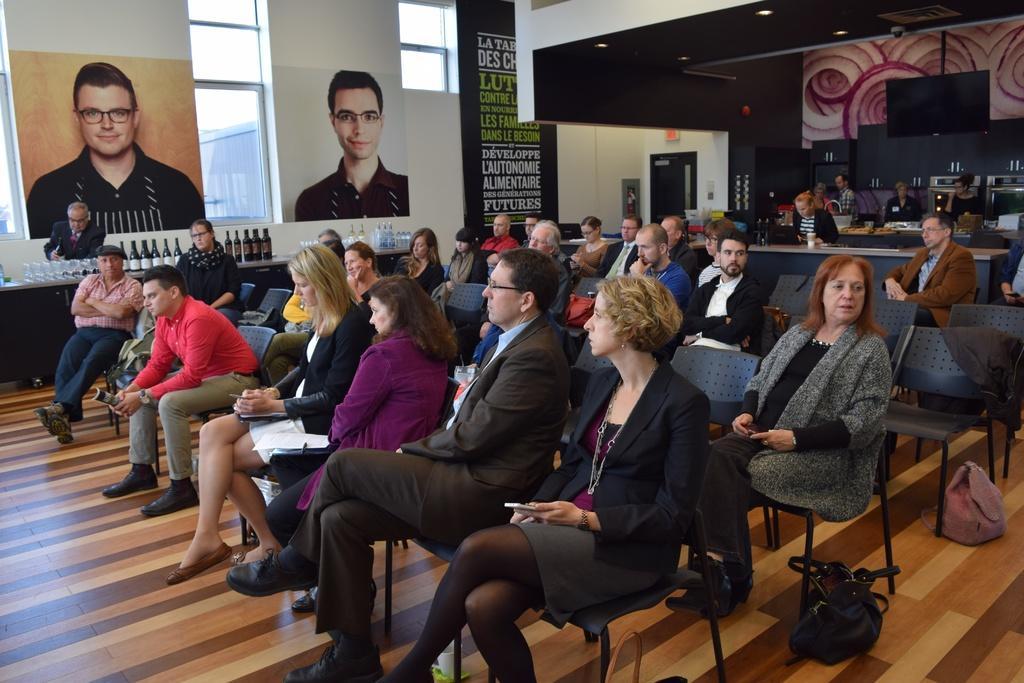Describe this image in one or two sentences. In the image there are many people sitting on the black chairs. To the left corner there is a table with bottles and glasses. Behind the table there is a man standing. In the background there is a wall with posters. And also there are few people standing in front of the tables. Also there are black cupboard, doors and walls. 